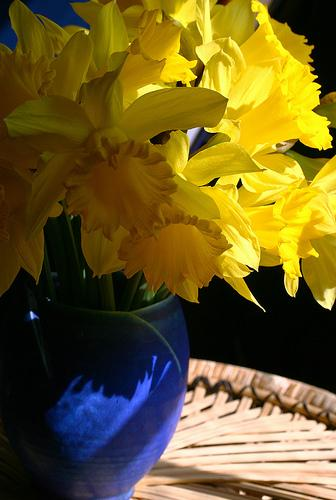Make an advertising statement about the vase in the image. Introducing our beautiful blue glass vase, perfect for showcasing your big yellow flowers and bringing a touch of elegance to your home decor. Describe the color and material of the table in the image. The table is brown and made of wicker. Mention the colors of the flowers and their stalks in the image. The flowers are yellow in color and their stalks are green. Create a question for a multi-choice VQA task based on the given information. b) Yellow Where is the object placed and what type of lighting can be observed in the scene? The object is placed inside by a window and there is sunshine in the area with some area shaded. Identify the color and material of the vase in the image. The vase is blue in color and made of glass. What type of flowers are present in the image and what is their size? The image has big yellow flowers. Using the given information, construct a sentence describing the appearance of the vase in the image. The vase in the image is blue, made of glass, and placed near a window with sunshine streaming in. Based on the information, what would be a prime location for placing the vase and flowers in a room? A prime location for placing the vase and flowers would be on a brown wicker table near a window with sunshine. Answer the following question based on the details provided: Are the flower stems visible, and what color are they? Yes, the flower stems are visible and they are green in color. 